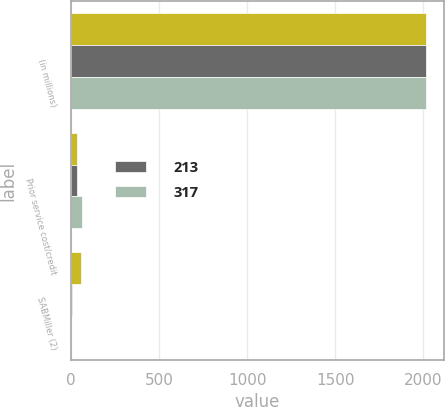Convert chart to OTSL. <chart><loc_0><loc_0><loc_500><loc_500><stacked_bar_chart><ecel><fcel>(in millions)<fcel>Prior service cost/credit<fcel>SABMiller (2)<nl><fcel>nan<fcel>2014<fcel>33<fcel>59<nl><fcel>213<fcel>2013<fcel>35<fcel>6<nl><fcel>317<fcel>2012<fcel>61<fcel>3<nl></chart> 